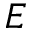<formula> <loc_0><loc_0><loc_500><loc_500>E</formula> 